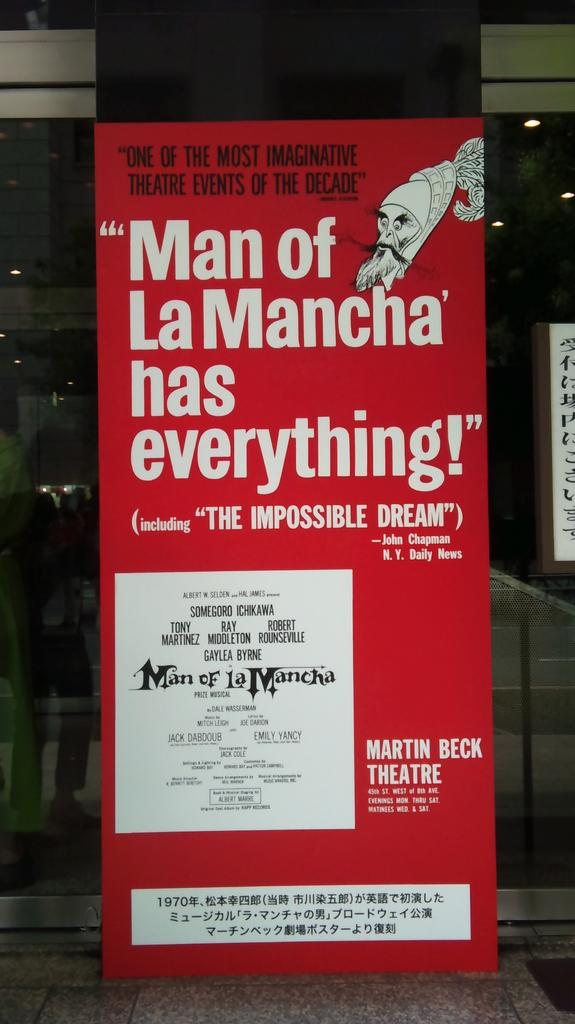What is the main object in the image? There is a banner in the image. What color is the banner? The banner is red in color. What can be found on the banner? There is text on the banner. What is visible in the top right-hand side of the image? There are ceiling lights in the top right-hand side of the image. What word is being changed by the banner in the image? There is no indication in the image that the banner is changing any words. 